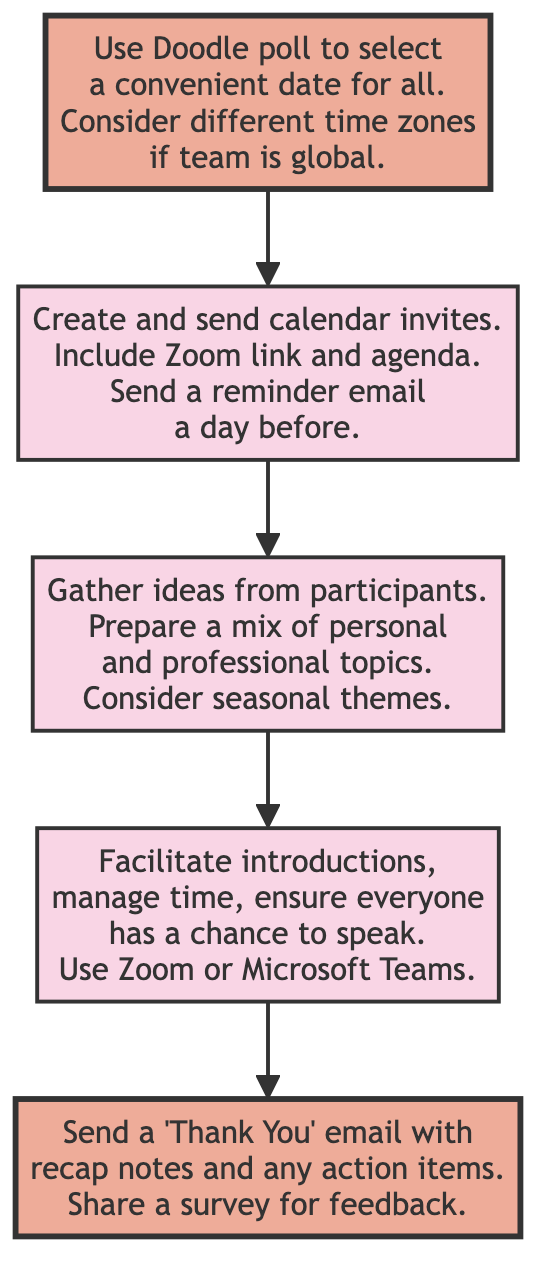What is the first step in the flow chart? The flow chart begins with the node "Selecting a Date," which is the initial action to be taken.
Answer: Selecting a Date How many nodes are in the diagram? The diagram contains five nodes: Selecting a Date, Sending Invites, Preparing Discussion Topics, Hosting the Session, and Post-Event Recap.
Answer: Five What node follows "Sending Invites"? The node that follows "Sending Invites" is "Preparing Discussion Topics," indicating the next action after sending the invites.
Answer: Preparing Discussion Topics What is included in the "Sending Invites" step? The "Sending Invites" step includes creating and sending calendar invites, which must have a Zoom link and agenda, and sending a reminder email a day before.
Answer: Create and send calendar invites Which two steps are highlighted in the diagram? The highlighted steps in the diagram are "Selecting a Date" and "Post-Event Recap," showing their importance in the flow.
Answer: Selecting a Date and Post-Event Recap How does "Post-Event Recap" relate to "Hosting the Session"? "Post-Event Recap" is the subsequent step after "Hosting the Session," meaning it occurs last in the process after the session has concluded.
Answer: Post-Event Recap What consideration should be made during "Selecting a Date"? During "Selecting a Date," it is important to consider different time zones, especially if the team is global, as this could impact the chosen date's convenience.
Answer: Different time zones What is the last action taken in the flow chart? The last action taken in the flow chart is the "Post-Event Recap," which finalizes the process after the hosting session.
Answer: Post-Event Recap 